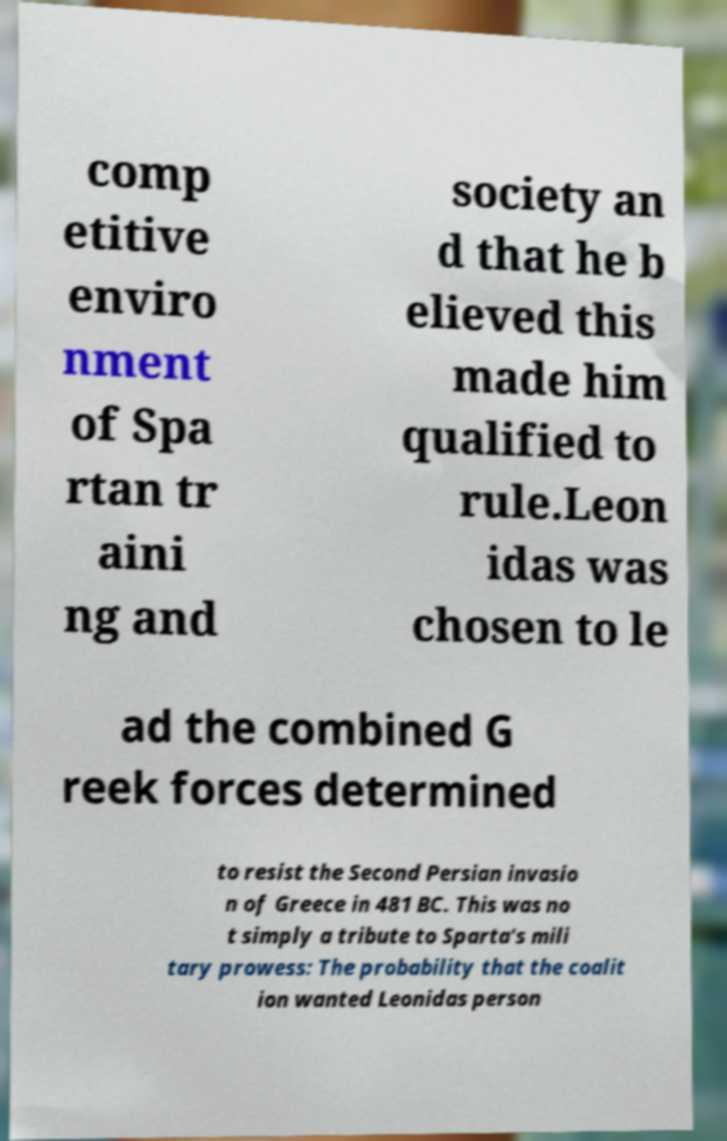There's text embedded in this image that I need extracted. Can you transcribe it verbatim? comp etitive enviro nment of Spa rtan tr aini ng and society an d that he b elieved this made him qualified to rule.Leon idas was chosen to le ad the combined G reek forces determined to resist the Second Persian invasio n of Greece in 481 BC. This was no t simply a tribute to Sparta's mili tary prowess: The probability that the coalit ion wanted Leonidas person 